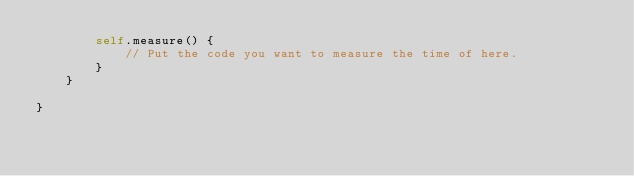Convert code to text. <code><loc_0><loc_0><loc_500><loc_500><_Swift_>        self.measure() {
            // Put the code you want to measure the time of here.
        }
    }
    
}
</code> 